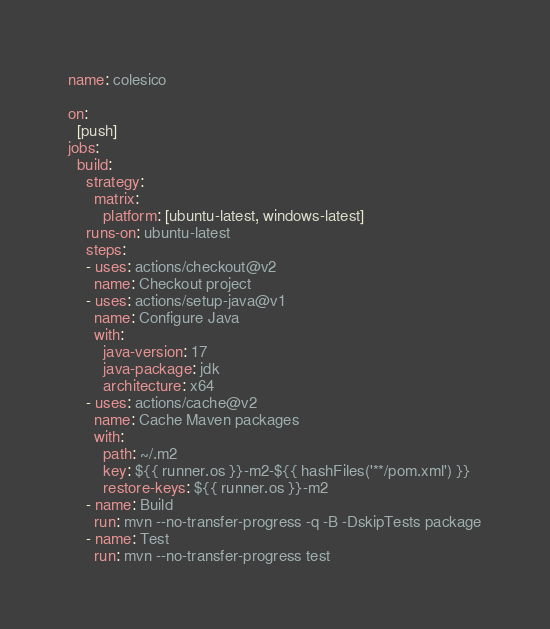<code> <loc_0><loc_0><loc_500><loc_500><_YAML_>name: colesico

on:
  [push]
jobs:
  build:
    strategy:
      matrix:
        platform: [ubuntu-latest, windows-latest]
    runs-on: ubuntu-latest
    steps:
    - uses: actions/checkout@v2
      name: Checkout project
    - uses: actions/setup-java@v1
      name: Configure Java
      with:
        java-version: 17
        java-package: jdk
        architecture: x64
    - uses: actions/cache@v2
      name: Cache Maven packages
      with:
        path: ~/.m2
        key: ${{ runner.os }}-m2-${{ hashFiles('**/pom.xml') }}
        restore-keys: ${{ runner.os }}-m2
    - name: Build
      run: mvn --no-transfer-progress -q -B -DskipTests package
    - name: Test
      run: mvn --no-transfer-progress test
</code> 